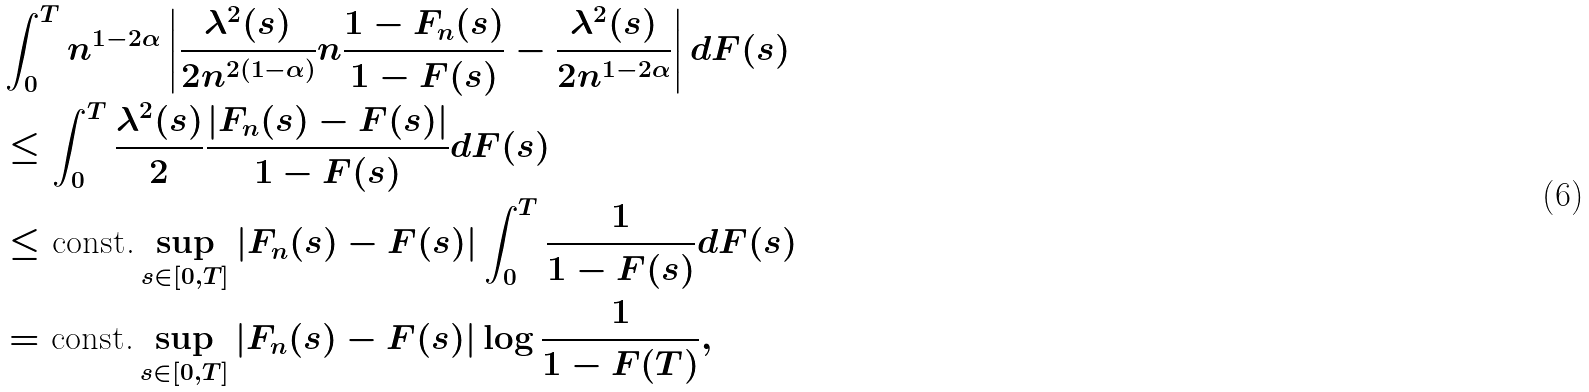<formula> <loc_0><loc_0><loc_500><loc_500>& \int _ { 0 } ^ { T } n ^ { 1 - 2 \alpha } \left | \frac { \lambda ^ { 2 } ( s ) } { 2 n ^ { 2 ( 1 - \alpha ) } } n \frac { 1 - F _ { n } ( s ) } { 1 - F ( s ) } - \frac { \lambda ^ { 2 } ( s ) } { 2 n ^ { 1 - 2 \alpha } } \right | d F ( s ) \\ & \leq \int _ { 0 } ^ { T } \frac { \lambda ^ { 2 } ( s ) } { 2 } \frac { | F _ { n } ( s ) - F ( s ) | } { 1 - F ( s ) } d F ( s ) \\ & \leq \text {const.} \sup _ { s \in [ 0 , T ] } | F _ { n } ( s ) - F ( s ) | \int _ { 0 } ^ { T } \frac { 1 } { 1 - F ( s ) } d F ( s ) \\ & = \text {const.} \sup _ { s \in [ 0 , T ] } | F _ { n } ( s ) - F ( s ) | \log \frac { 1 } { 1 - F ( T ) } ,</formula> 